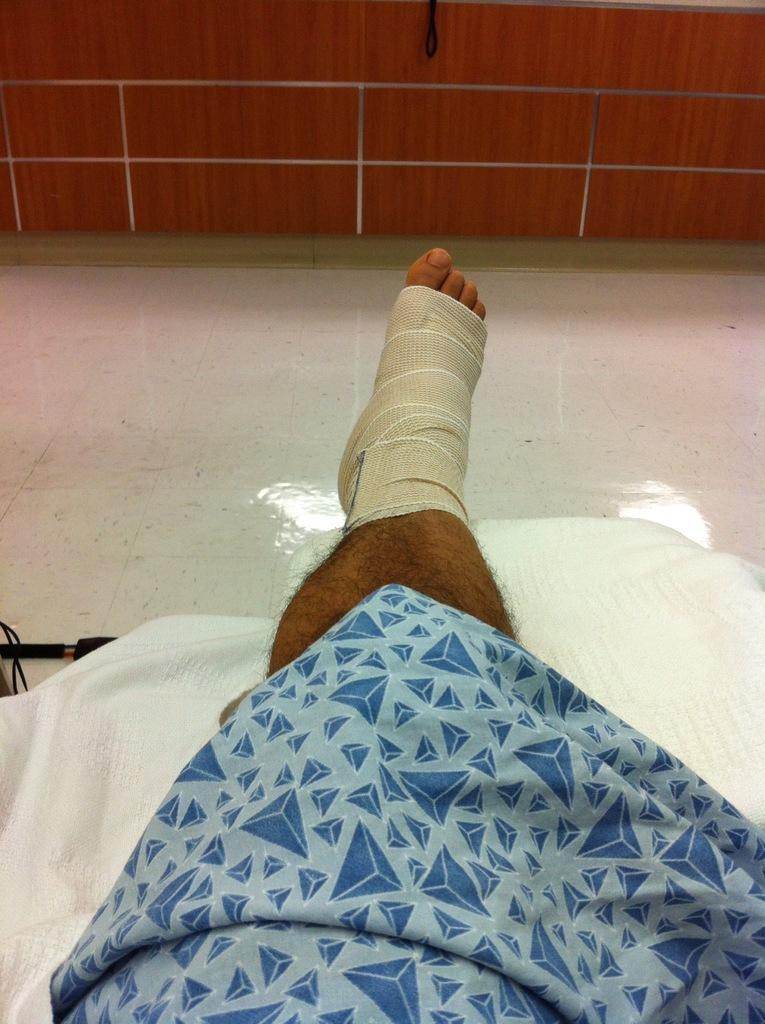What is the main focus of the image? The main focus of the image is a person's leg with a bandage. What else can be seen in the image besides the leg? There are clothes and an object on the left side of the image. What is visible in the background of the image? There is a wall and railings visible in the background of the image. Can you tell me what kind of plant is growing on the person's leg in the image? There is no plant growing on the person's leg in the image; it is a bandage covering the leg. What is your uncle doing in the image? There is no mention of an uncle or any person's actions in the image, as the focus is on the person's leg with a bandage. 